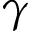<formula> <loc_0><loc_0><loc_500><loc_500>\gamma</formula> 